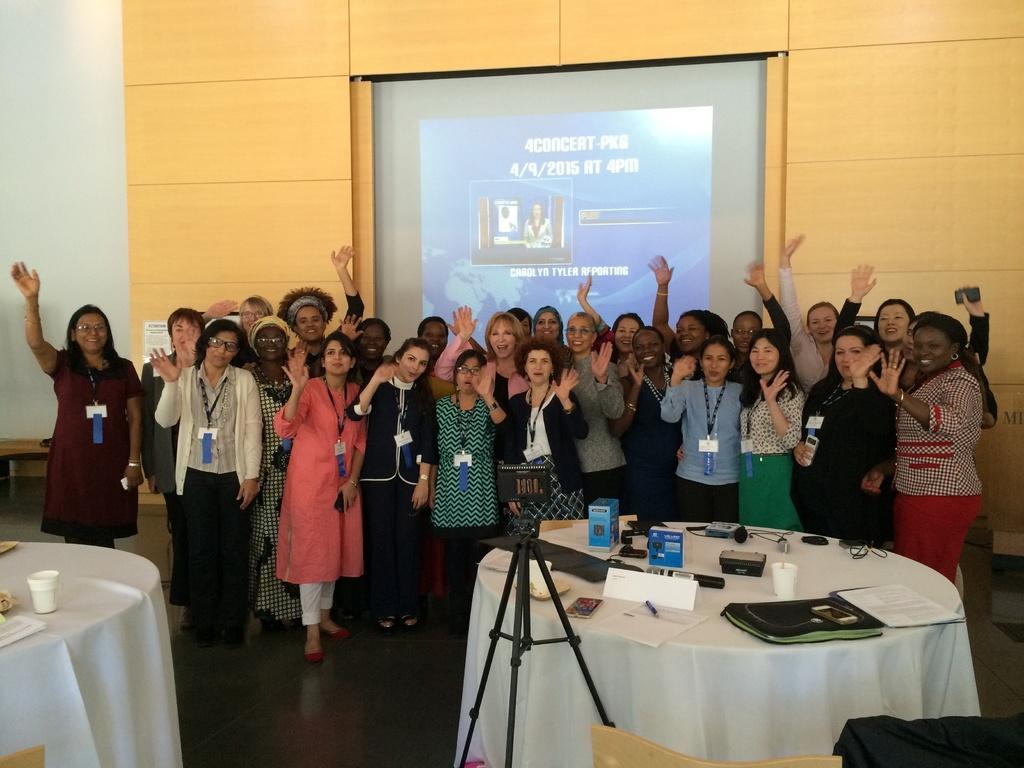In one or two sentences, can you explain what this image depicts? There are some group of people standing here and posing for a picture. All of them were women. In the background there is a projector display screen. In front of them there is a table and some accessories were placed on it. 